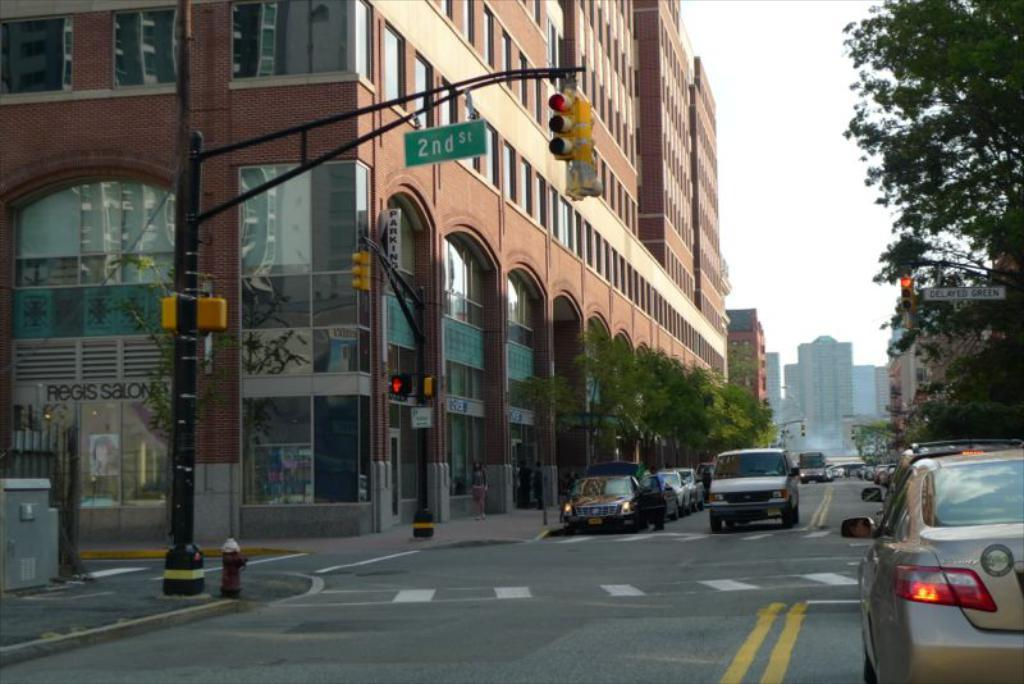What is the main feature of the image? There is a road in the image. What can be seen on the road? There are vehicles on the road. What is visible around the road? There are trees and buildings around the road. What infrastructure is present to regulate traffic? Traffic signal poles are present in the image. What type of discussion is taking place between the trees in the image? There is no discussion taking place between the trees in the image, as trees do not engage in discussions. 